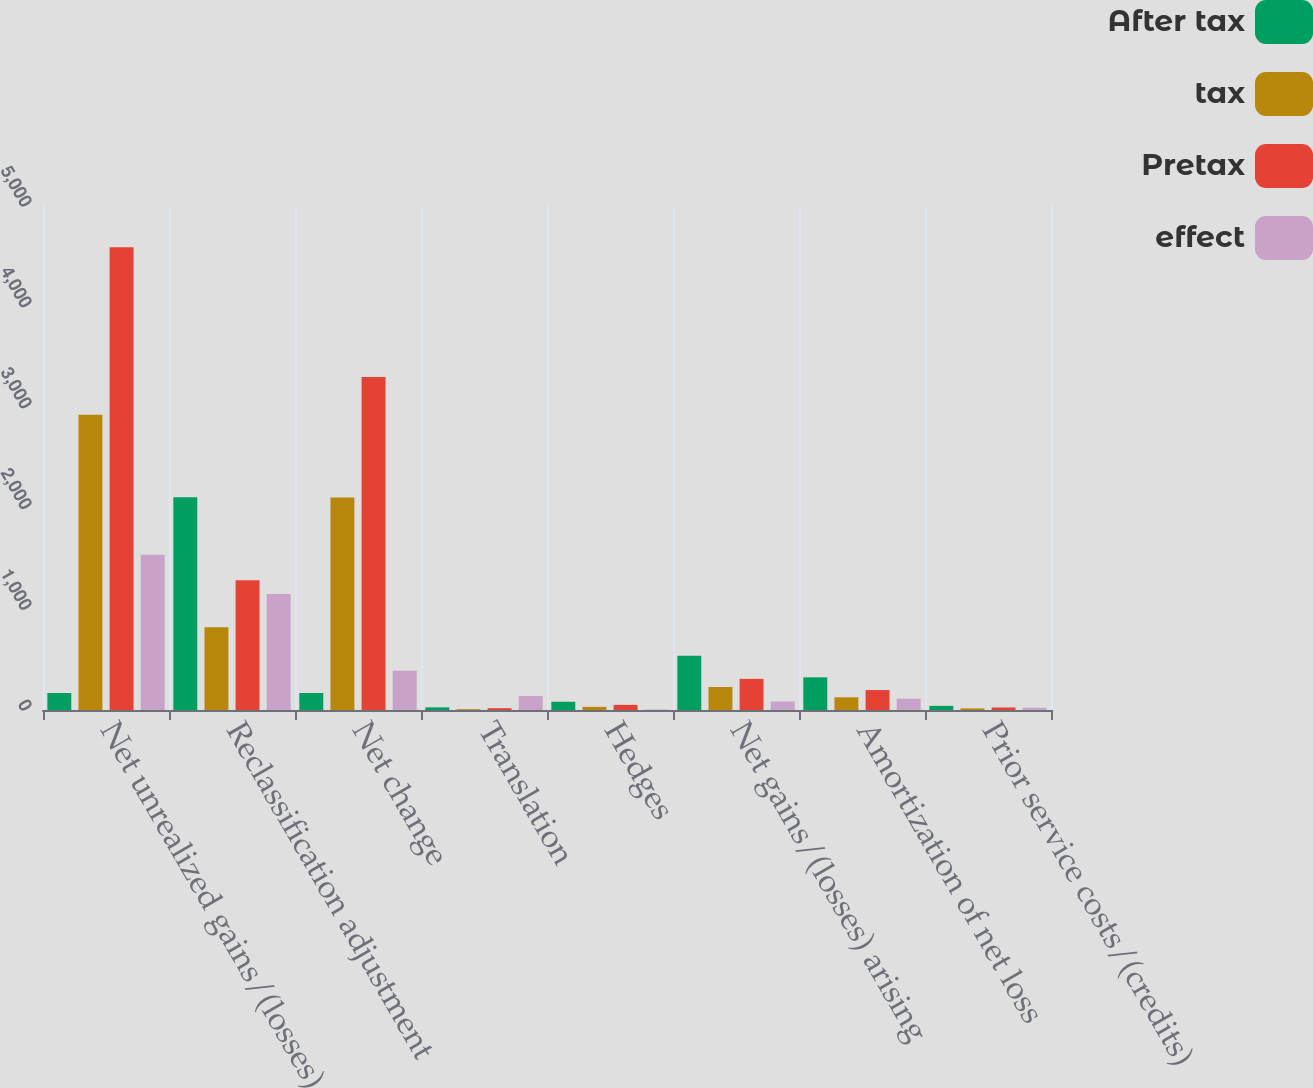<chart> <loc_0><loc_0><loc_500><loc_500><stacked_bar_chart><ecel><fcel>Net unrealized gains/(losses)<fcel>Reclassification adjustment<fcel>Net change<fcel>Translation<fcel>Hedges<fcel>Net gains/(losses) arising<fcel>Amortization of net loss<fcel>Prior service costs/(credits)<nl><fcel>After tax<fcel>168.5<fcel>2110<fcel>168.5<fcel>26<fcel>82<fcel>537<fcel>324<fcel>41<nl><fcel>tax<fcel>2930<fcel>822<fcel>2108<fcel>8<fcel>31<fcel>228<fcel>126<fcel>16<nl><fcel>Pretax<fcel>4591<fcel>1288<fcel>3303<fcel>18<fcel>51<fcel>309<fcel>198<fcel>25<nl><fcel>effect<fcel>1540<fcel>1150<fcel>390<fcel>139<fcel>5<fcel>84<fcel>112<fcel>22<nl></chart> 